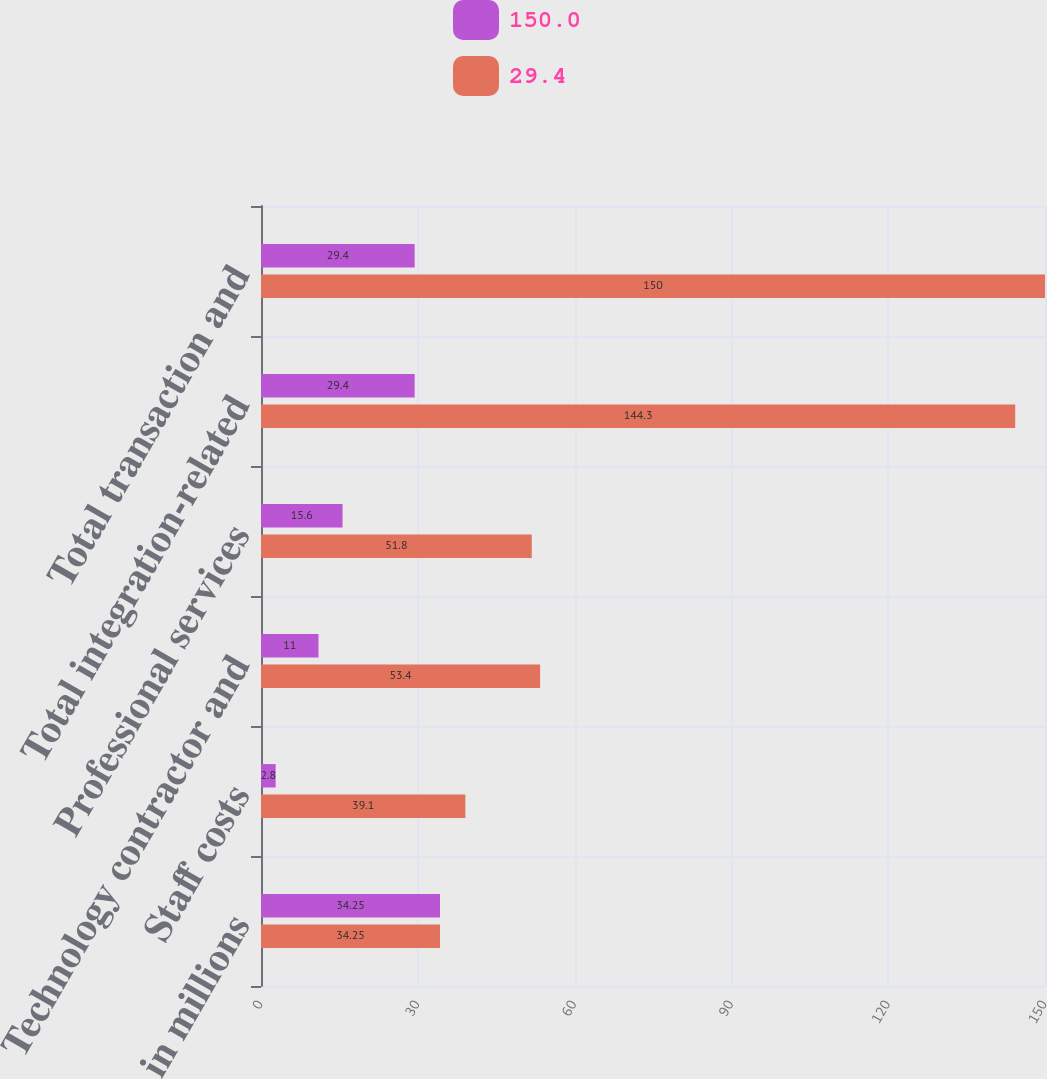<chart> <loc_0><loc_0><loc_500><loc_500><stacked_bar_chart><ecel><fcel>in millions<fcel>Staff costs<fcel>Technology contractor and<fcel>Professional services<fcel>Total integration-related<fcel>Total transaction and<nl><fcel>150<fcel>34.25<fcel>2.8<fcel>11<fcel>15.6<fcel>29.4<fcel>29.4<nl><fcel>29.4<fcel>34.25<fcel>39.1<fcel>53.4<fcel>51.8<fcel>144.3<fcel>150<nl></chart> 